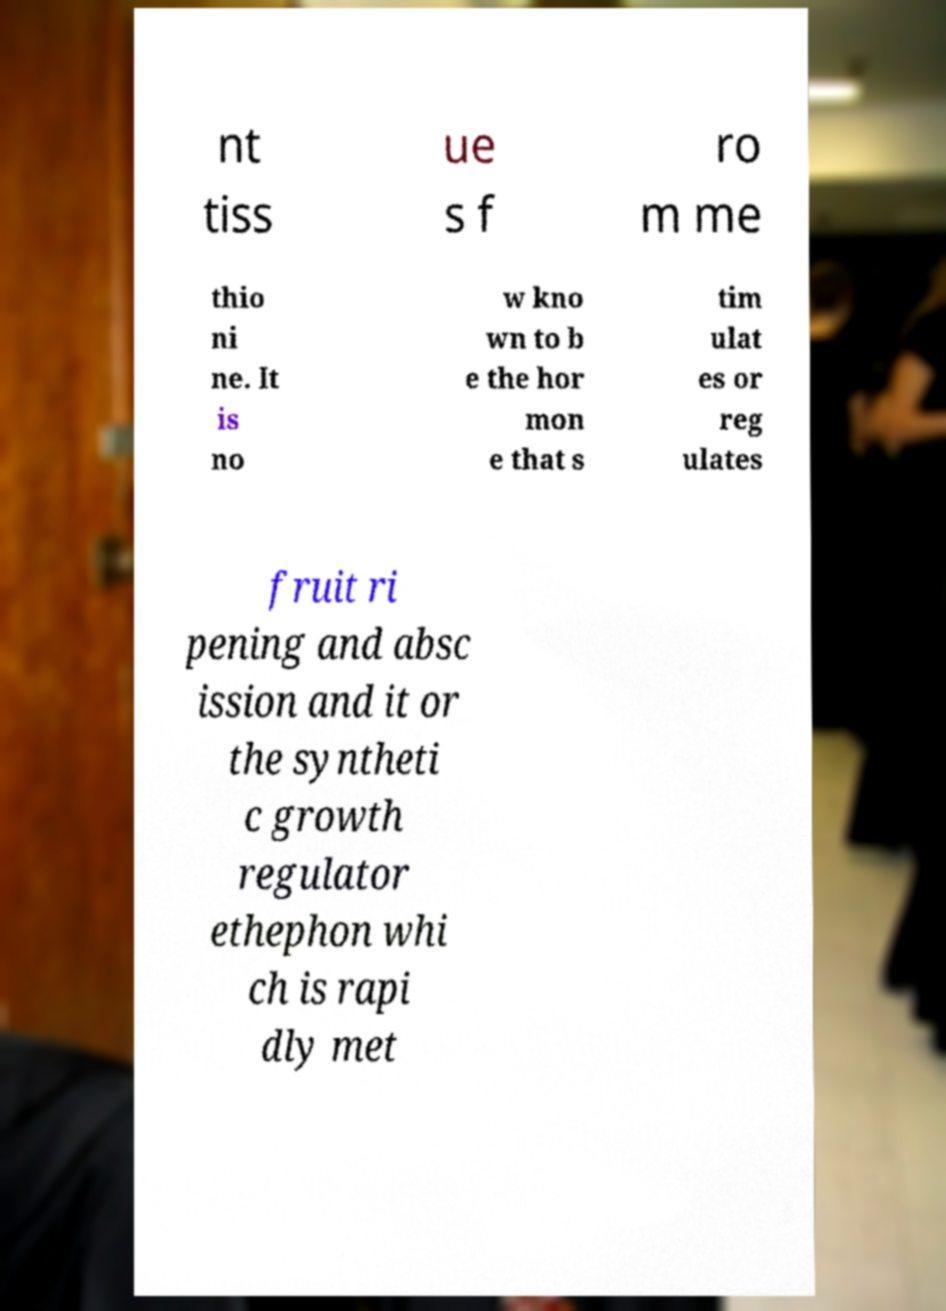Could you assist in decoding the text presented in this image and type it out clearly? nt tiss ue s f ro m me thio ni ne. It is no w kno wn to b e the hor mon e that s tim ulat es or reg ulates fruit ri pening and absc ission and it or the syntheti c growth regulator ethephon whi ch is rapi dly met 